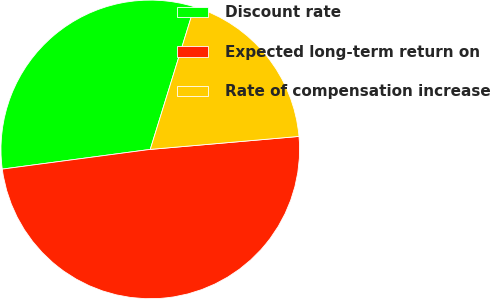Convert chart. <chart><loc_0><loc_0><loc_500><loc_500><pie_chart><fcel>Discount rate<fcel>Expected long-term return on<fcel>Rate of compensation increase<nl><fcel>31.88%<fcel>49.28%<fcel>18.84%<nl></chart> 